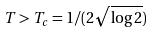Convert formula to latex. <formula><loc_0><loc_0><loc_500><loc_500>T > T _ { c } = 1 / ( 2 \sqrt { \log 2 } )</formula> 